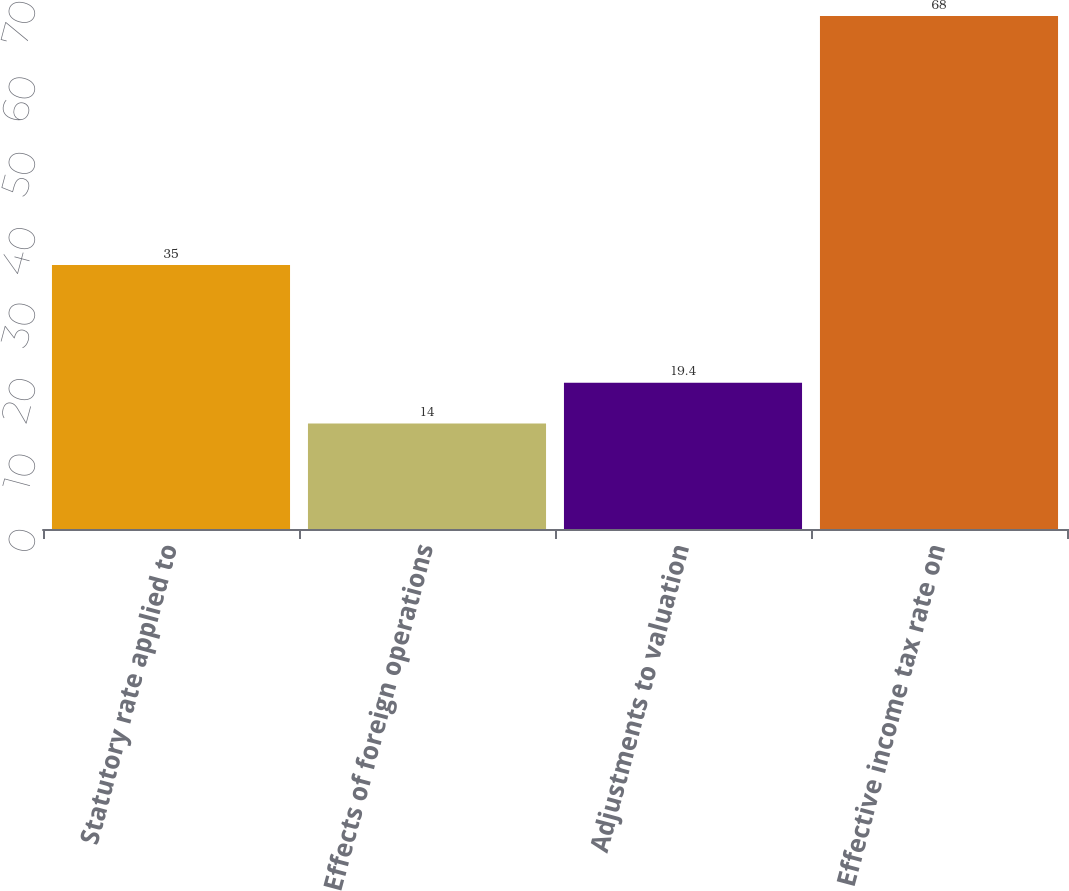Convert chart to OTSL. <chart><loc_0><loc_0><loc_500><loc_500><bar_chart><fcel>Statutory rate applied to<fcel>Effects of foreign operations<fcel>Adjustments to valuation<fcel>Effective income tax rate on<nl><fcel>35<fcel>14<fcel>19.4<fcel>68<nl></chart> 